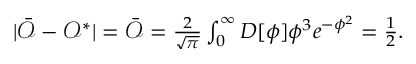Convert formula to latex. <formula><loc_0><loc_0><loc_500><loc_500>\begin{array} { r } { | \bar { \mathcal { O } } - \mathcal { O } ^ { * } | = \bar { \mathcal { O } } = \frac { 2 } { \sqrt { \pi } } \int _ { 0 } ^ { \infty } D [ \phi ] \phi ^ { 3 } e ^ { - \phi ^ { 2 } } = \frac { 1 } { 2 } . } \end{array}</formula> 